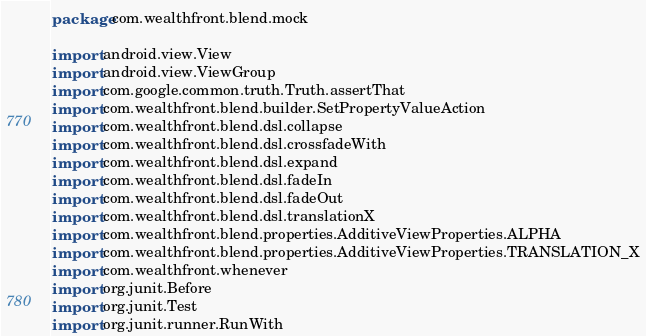<code> <loc_0><loc_0><loc_500><loc_500><_Kotlin_>package com.wealthfront.blend.mock

import android.view.View
import android.view.ViewGroup
import com.google.common.truth.Truth.assertThat
import com.wealthfront.blend.builder.SetPropertyValueAction
import com.wealthfront.blend.dsl.collapse
import com.wealthfront.blend.dsl.crossfadeWith
import com.wealthfront.blend.dsl.expand
import com.wealthfront.blend.dsl.fadeIn
import com.wealthfront.blend.dsl.fadeOut
import com.wealthfront.blend.dsl.translationX
import com.wealthfront.blend.properties.AdditiveViewProperties.ALPHA
import com.wealthfront.blend.properties.AdditiveViewProperties.TRANSLATION_X
import com.wealthfront.whenever
import org.junit.Before
import org.junit.Test
import org.junit.runner.RunWith</code> 